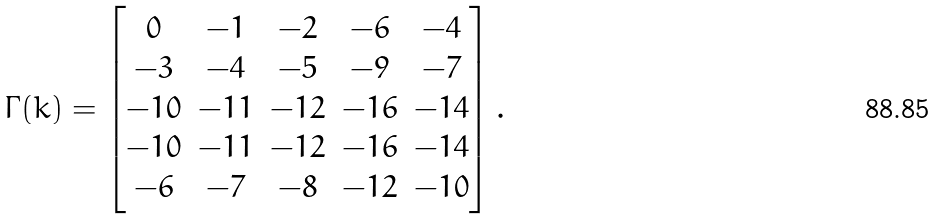<formula> <loc_0><loc_0><loc_500><loc_500>\Gamma ( k ) = \begin{bmatrix} 0 & - 1 & - 2 & - 6 & - 4 \\ - 3 & - 4 & - 5 & - 9 & - 7 \\ - 1 0 & - 1 1 & - 1 2 & - 1 6 & - 1 4 \\ - 1 0 & - 1 1 & - 1 2 & - 1 6 & - 1 4 \\ - 6 & - 7 & - 8 & - 1 2 & - 1 0 \end{bmatrix} .</formula> 